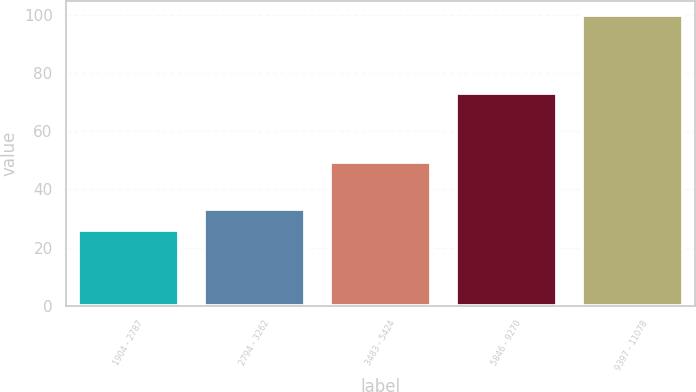Convert chart. <chart><loc_0><loc_0><loc_500><loc_500><bar_chart><fcel>1904 - 2787<fcel>2794 - 3262<fcel>3483 - 5424<fcel>5846 - 9270<fcel>9397 - 11078<nl><fcel>25.91<fcel>33.31<fcel>49.53<fcel>73.03<fcel>99.94<nl></chart> 